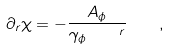<formula> <loc_0><loc_0><loc_500><loc_500>\partial _ { r } \chi = - \frac { A _ { \phi } } { \gamma _ { \phi } \, \quad ^ { r } } \, \quad ,</formula> 